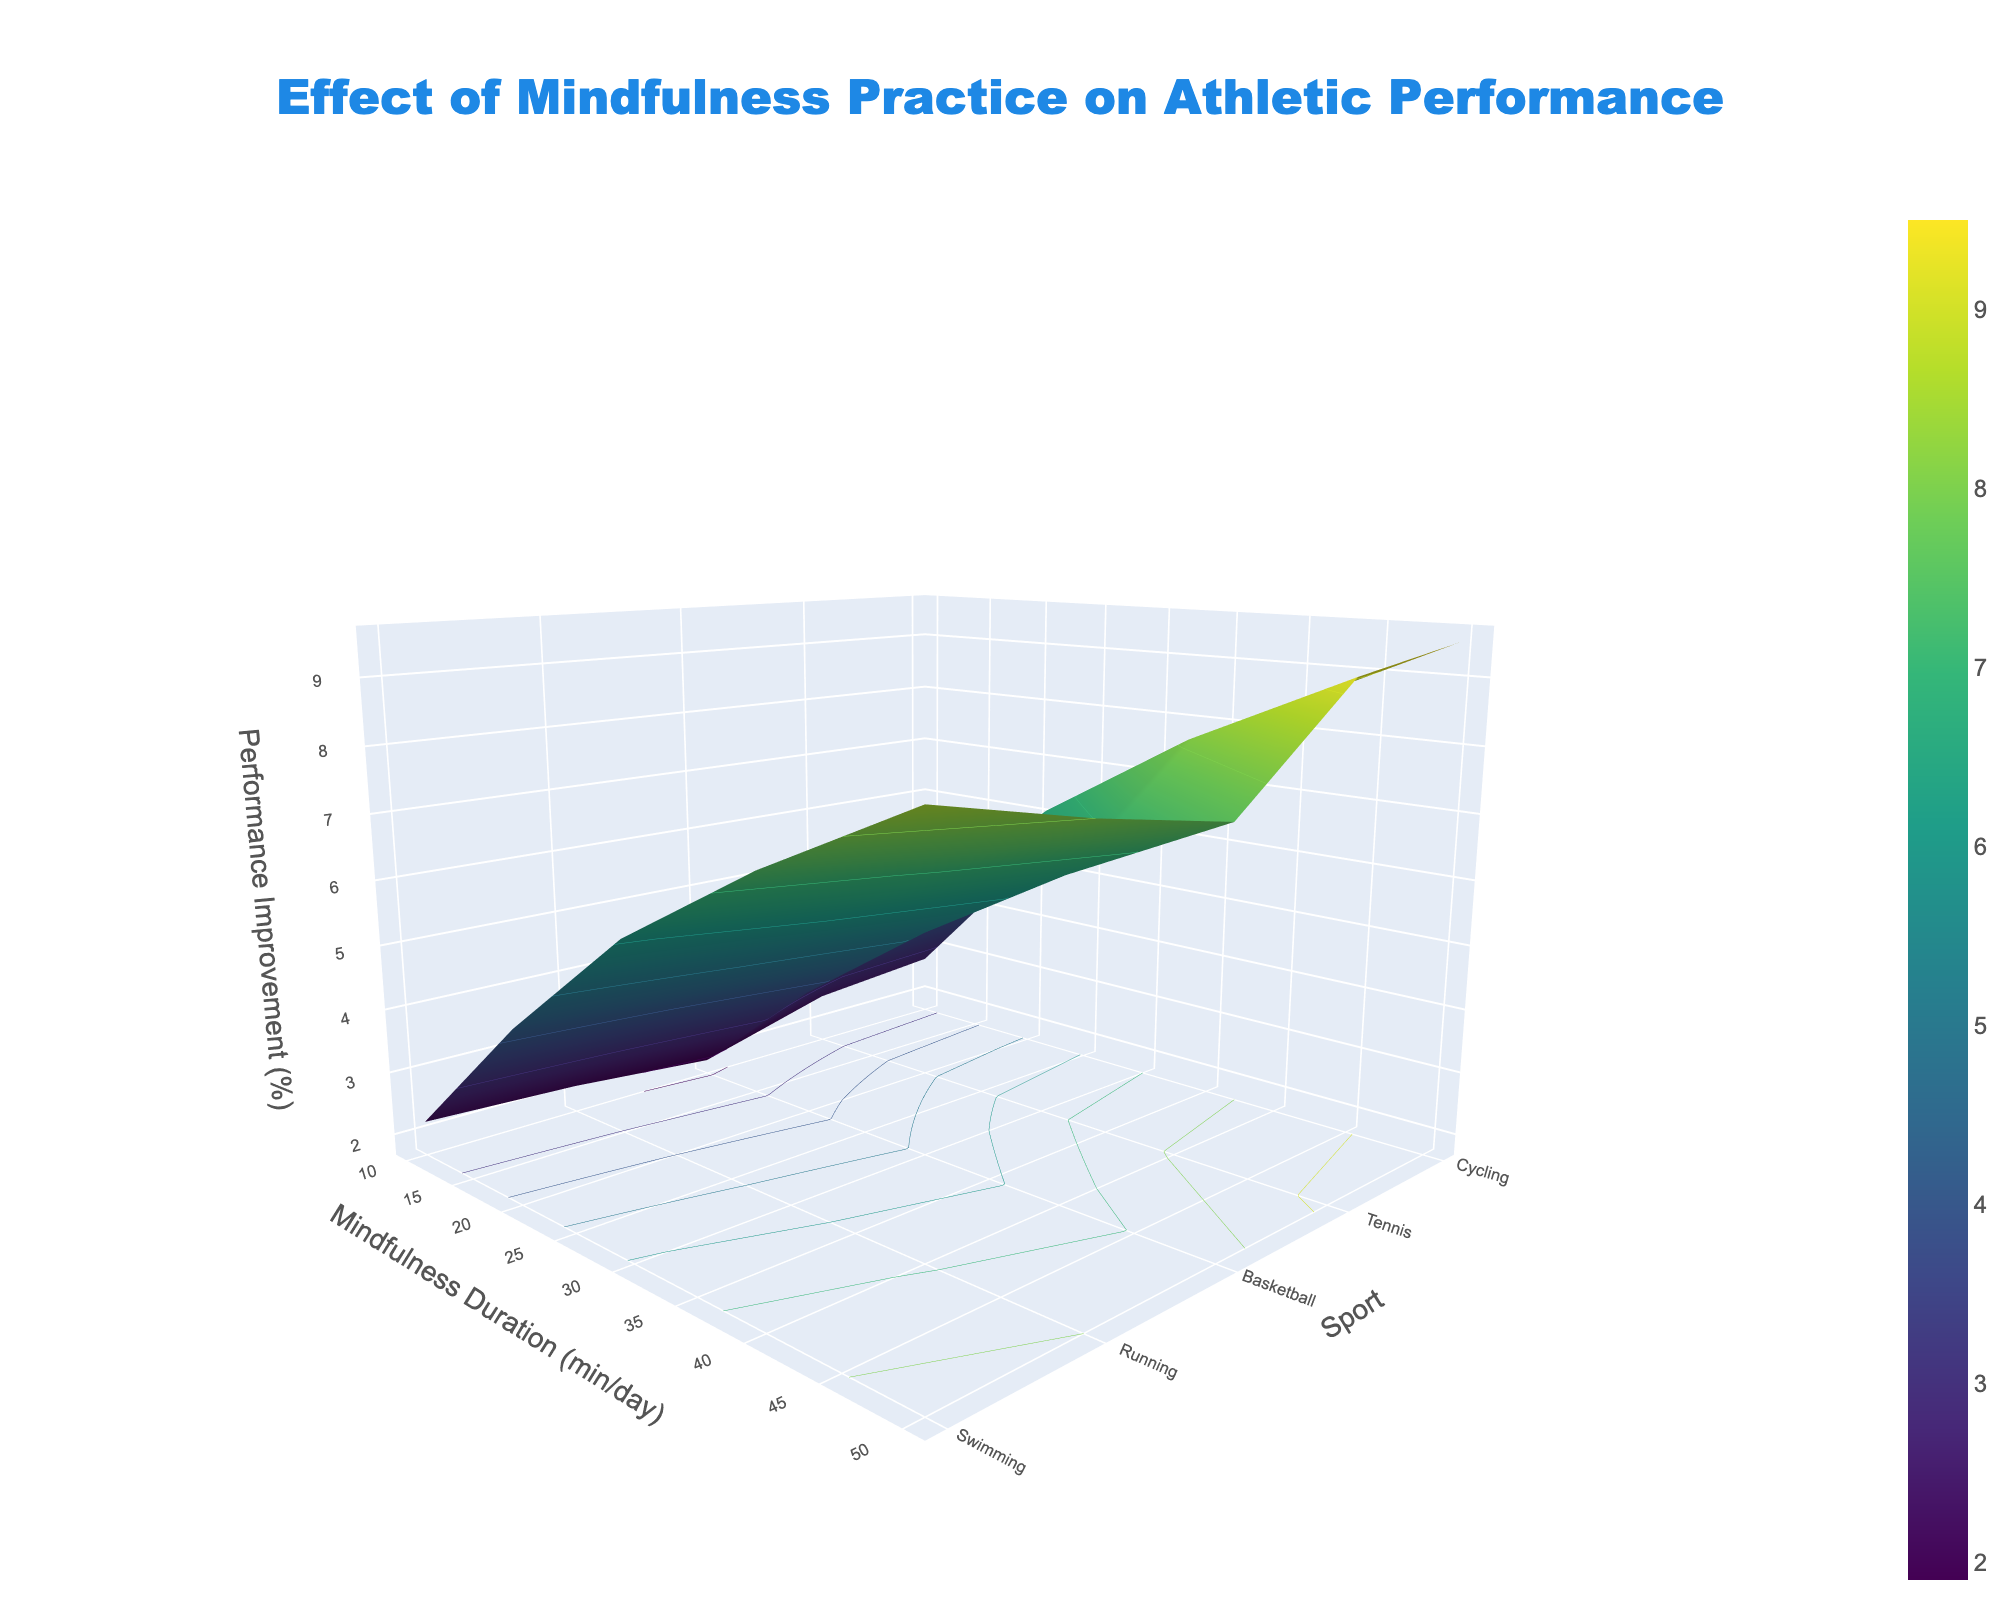What's the title of the figure? The title is usually displayed at the top of the figure. In this case, it is "Effect of Mindfulness Practice on Athletic Performance," which is centered and uses the color #1E88E5 and font 'Arial Black' in size 24.
Answer: Effect of Mindfulness Practice on Athletic Performance Which axis represents mindfulness duration? By examining the labels of the axes, the x-axis is labeled 'Mindfulness Duration (min/day)', indicating this axis represents the duration of mindfulness practice.
Answer: x-axis What is the performance improvement for Tennis with a 30 min/day mindfulness duration? Locate Tennis on the y-axis and 30 min/day on the x-axis, then find the corresponding z-value or height of the surface plot. According to the table, it is 7.0%.
Answer: 7.0% Which sport shows the greatest performance improvement at 50 min/day mindfulness? Compare the z-values at 50 min/day for all sports. Swimming (9.2), Running (7.6), Basketball (8.5), Tennis (9.5), and Cycling (8.0). Tennis has the highest value.
Answer: Tennis At what mindfulness duration do athletes experience the most significant performance improvements? Examine all the z-axis values across sports and durations. The performance improvements generally increase as the mindfulness duration increases, with the highest at 50 min/day.
Answer: 50 min/day How does performance improvement compare between Running and Basketball at 20 min/day? Compare the z-values for Running and Basketball at 20 min/day. Running has a performance improvement of 3.7%, and Basketball has 4.3%. Basketball has a slightly higher improvement.
Answer: Basketball What is the average performance improvement for Cycling across all durations? Sum all the performance improvements for Cycling (2.1 + 4.0 + 5.6 + 6.9 + 8.0) and divide by the number of data points (5). The average is (2.1 + 4.0 + 5.6 + 6.9 + 8.0) / 5 = 5.32%.
Answer: 5.32% Which sport has the smallest performance improvement at 30 min/day of mindfulness practice? Compare the z-values for all sports at 30 min/day. Swimming (6.7%), Running (5.2%), Basketball (6.1%), Tennis (7.0%), and Cycling (5.6%). Running has the smallest improvement.
Answer: Running Does performance improvement differ more significantly between sports or between mindfulness durations? Compare the variations in z-values across sports and mindfulness durations. The improvements are more consistent across sports, with greater variability as mindfulness duration increases.
Answer: mindfulness durations What is the range of performance improvement for Swimming across all mindfulness durations? Identify the maximum and minimum performance improvements for Swimming across all durations. Maximum is 9.2% at 50 min/day and minimum is 2.5% at 10 min/day. The range is 9.2 - 2.5 = 6.7%.
Answer: 6.7% 